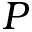Convert formula to latex. <formula><loc_0><loc_0><loc_500><loc_500>P</formula> 